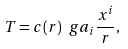<formula> <loc_0><loc_0><loc_500><loc_500>T = c ( r ) \ g a _ { i } \frac { x ^ { i } } { r } ,</formula> 